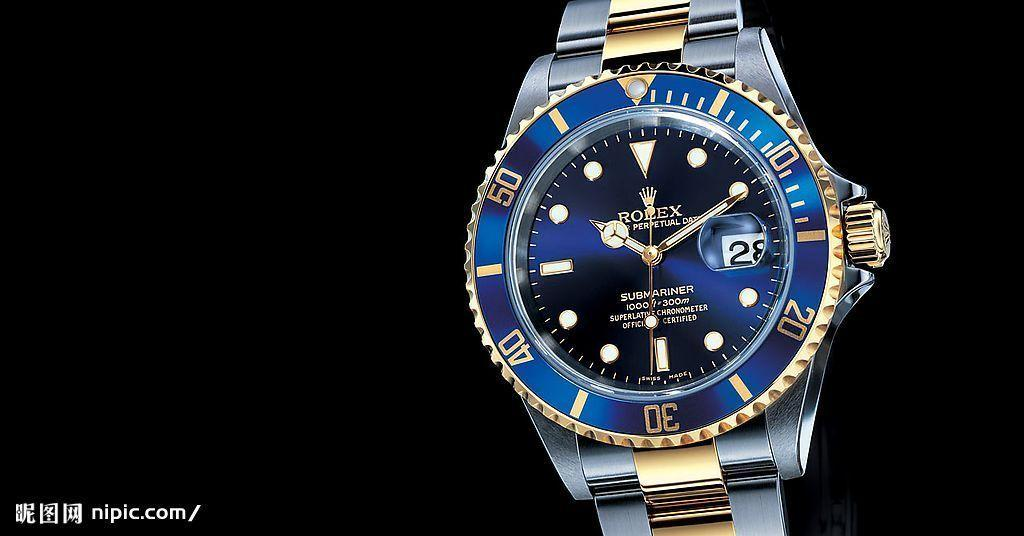Provide a one-sentence caption for the provided image. A Rolex watch with a blue face shows the time as 10:10. 